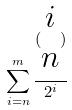Convert formula to latex. <formula><loc_0><loc_0><loc_500><loc_500>\sum _ { i = n } ^ { m } \frac { ( \begin{matrix} i \\ n \end{matrix} ) } { 2 ^ { i } }</formula> 